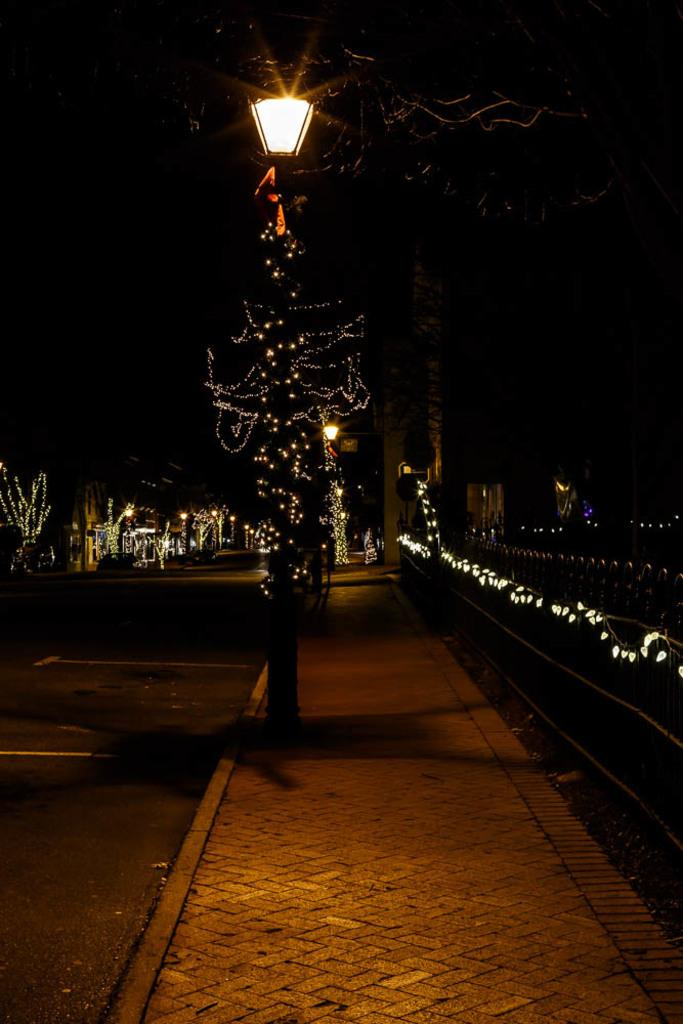What type of path is visible in the image? There is a road and a footpath in the image. What is located on the right side of the image? There is fencing on the right side of the image. What type of vegetation is present in the image? There are trees with lights in the image. What type of plough is being used by the woman in the image? There is no woman or plough present in the image. What is the interest rate for the loan mentioned in the image? There is no mention of a loan or interest rate in the image. 